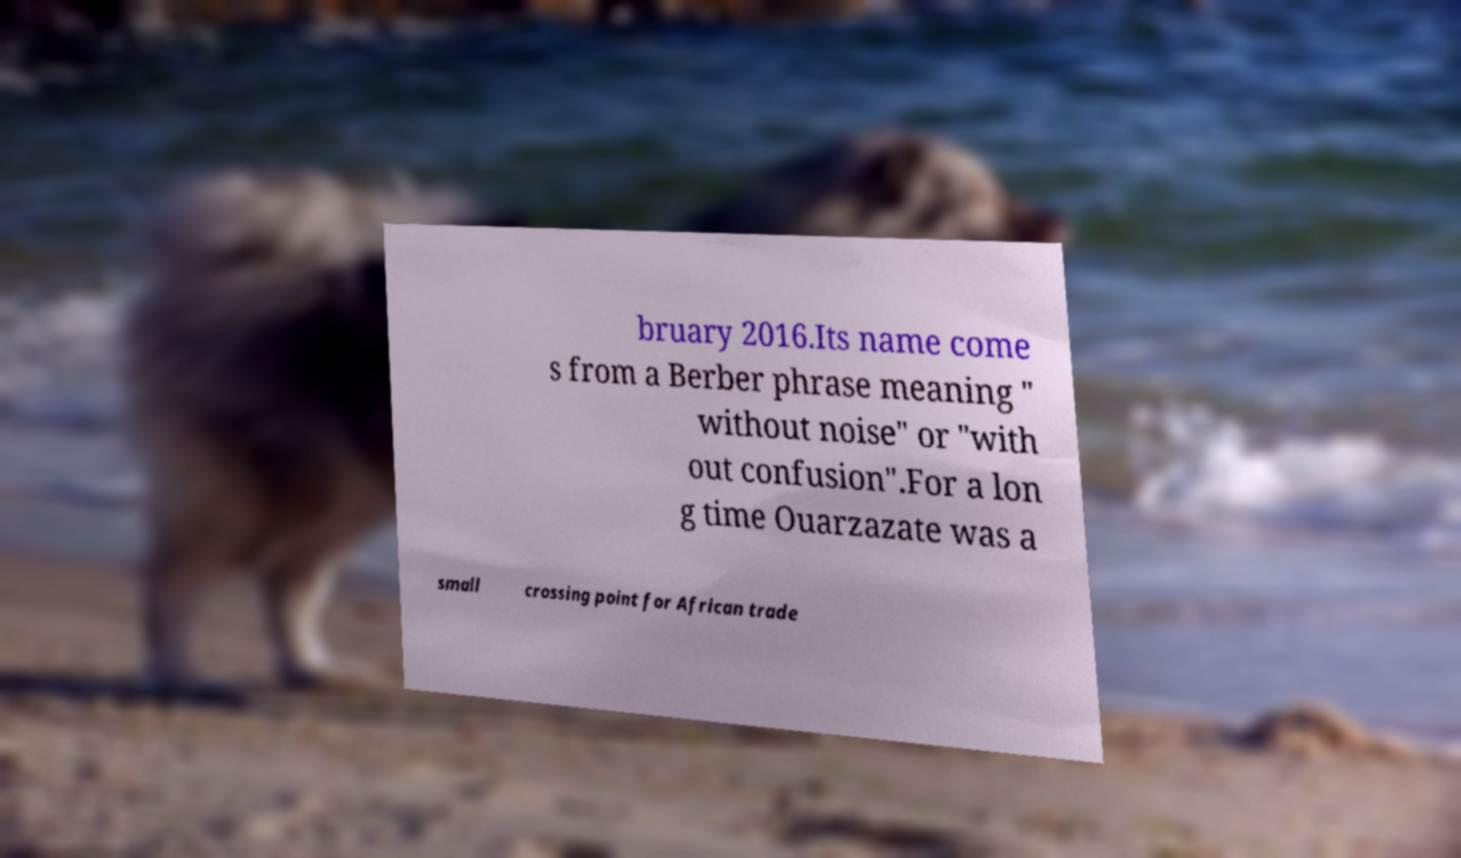Can you read and provide the text displayed in the image?This photo seems to have some interesting text. Can you extract and type it out for me? bruary 2016.Its name come s from a Berber phrase meaning " without noise" or "with out confusion".For a lon g time Ouarzazate was a small crossing point for African trade 